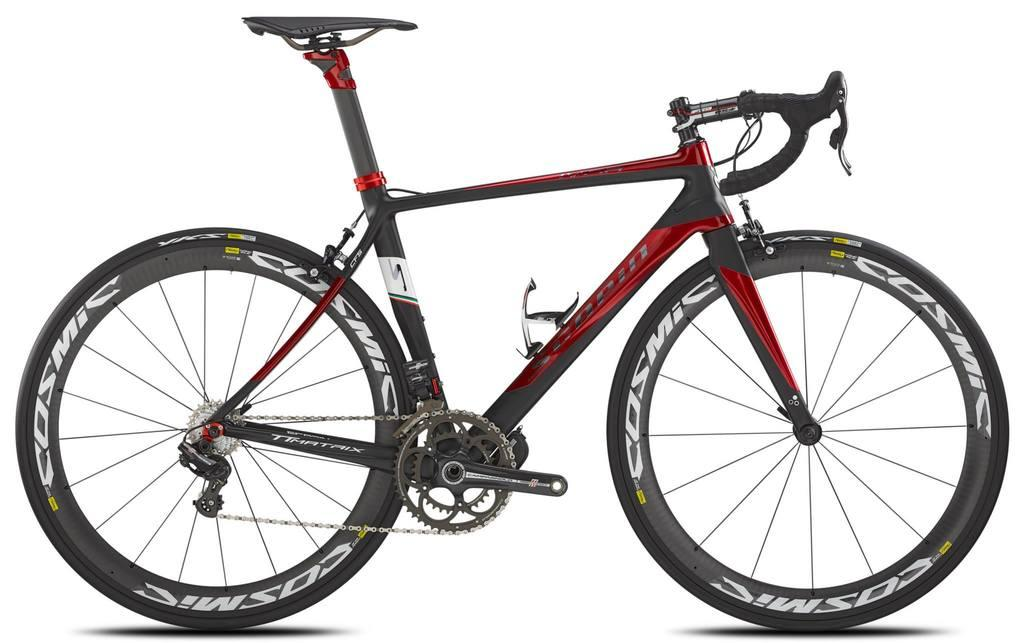What is the main object in the image? There is a bicycle in the image. Can you describe the bicycle in more detail? Unfortunately, the facts provided do not give any additional details about the bicycle. Is the bicycle being used or is it stationary in the image? The facts provided do not specify whether the bicycle is being used or not. What type of weather can be seen in the image? The facts provided do not mention any weather conditions, and the image does not show any weather elements. 